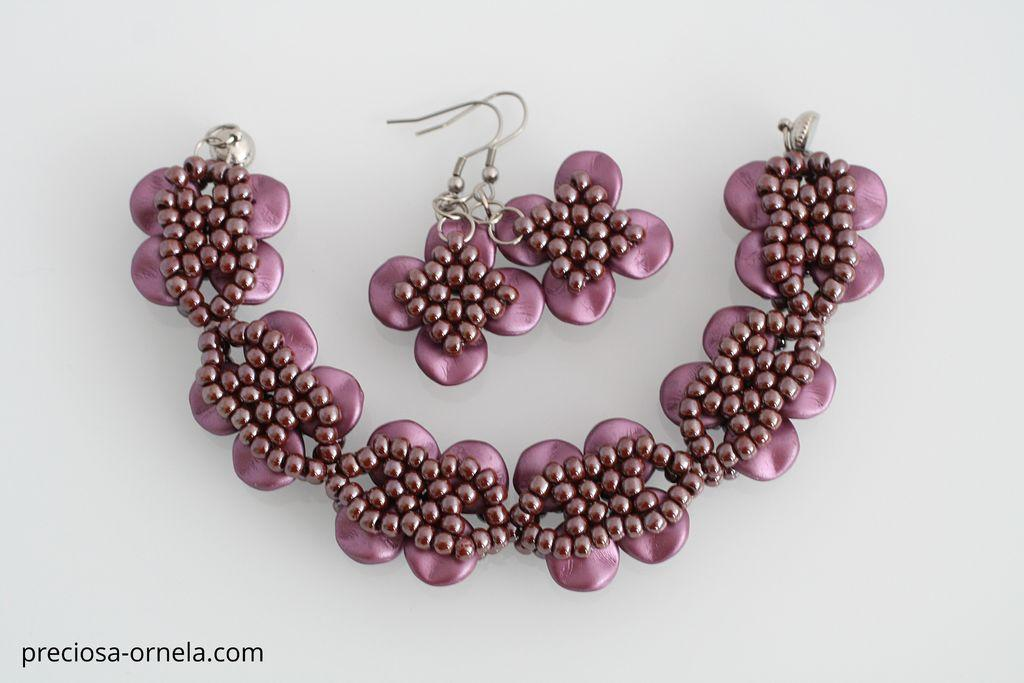What type of jewelry can be seen in the image? There is a necklace and earrings in the image. What is the setting or background of the image? The background of the image appears to be a plane. Is there any text present in the image? Yes, there is some text at the left bottom of the image. Can you hear the owl hooting in the image? There is no owl present in the image, so it is not possible to hear it hooting. What type of jewelry is the owl wearing in the image? There is no owl or any other creature present in the image, so it is not possible to determine what type of jewelry they might be wearing. 